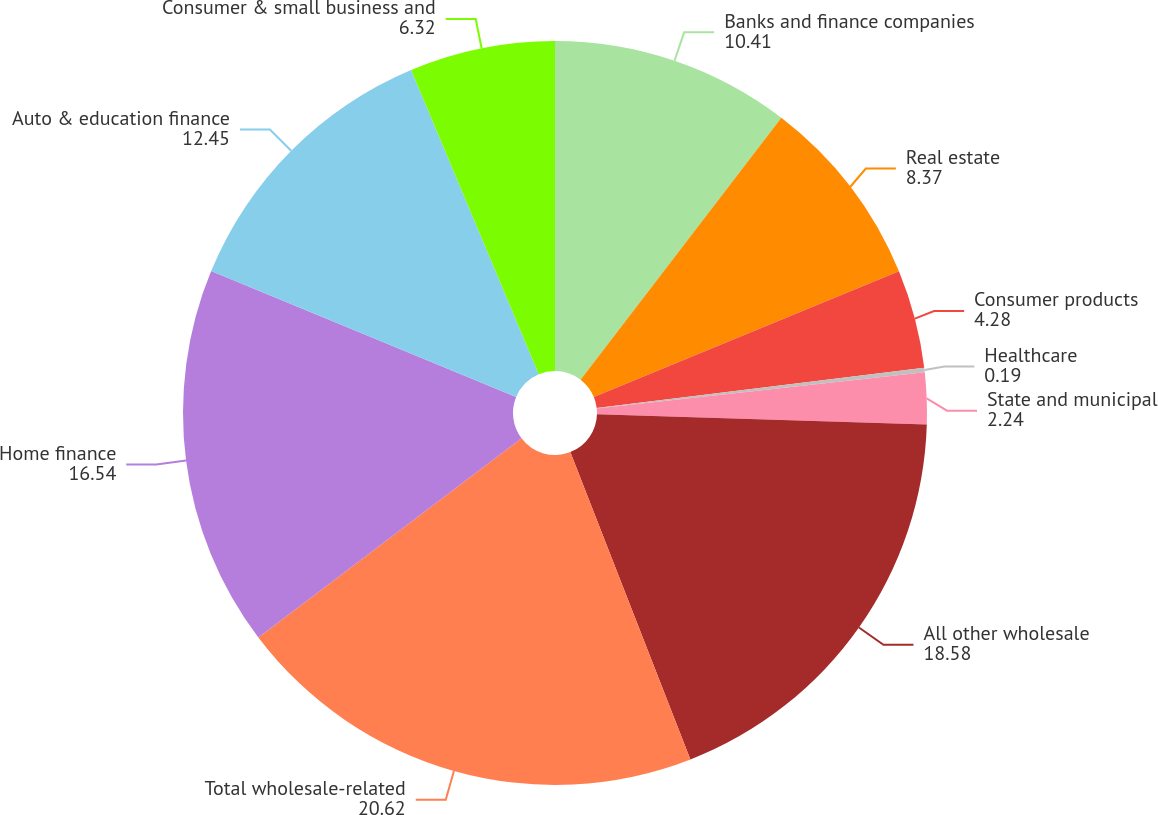Convert chart to OTSL. <chart><loc_0><loc_0><loc_500><loc_500><pie_chart><fcel>Banks and finance companies<fcel>Real estate<fcel>Consumer products<fcel>Healthcare<fcel>State and municipal<fcel>All other wholesale<fcel>Total wholesale-related<fcel>Home finance<fcel>Auto & education finance<fcel>Consumer & small business and<nl><fcel>10.41%<fcel>8.37%<fcel>4.28%<fcel>0.19%<fcel>2.24%<fcel>18.58%<fcel>20.62%<fcel>16.54%<fcel>12.45%<fcel>6.32%<nl></chart> 